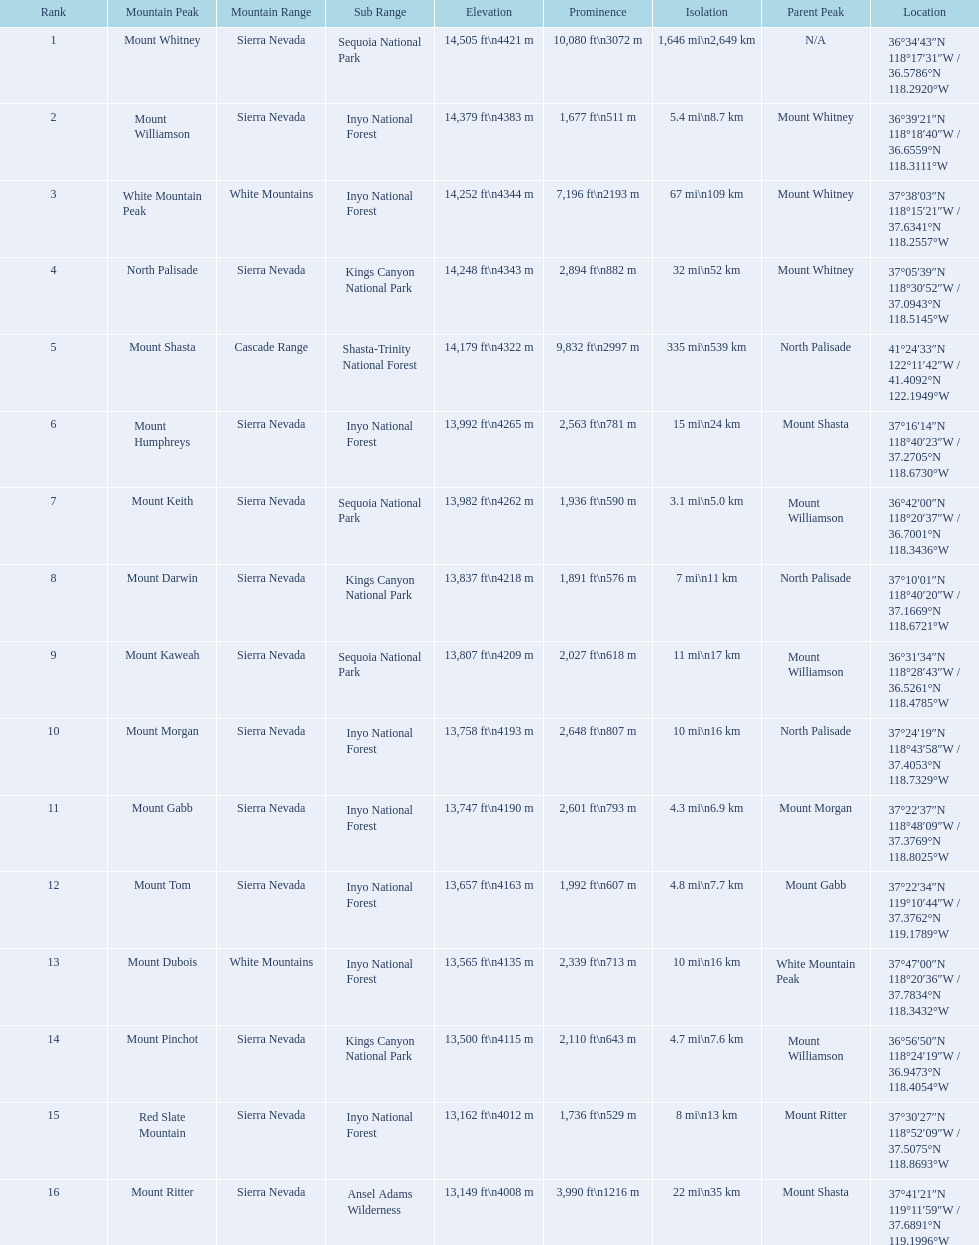What are the prominence lengths higher than 10,000 feet? 10,080 ft\n3072 m. What mountain peak has a prominence of 10,080 feet? Mount Whitney. 